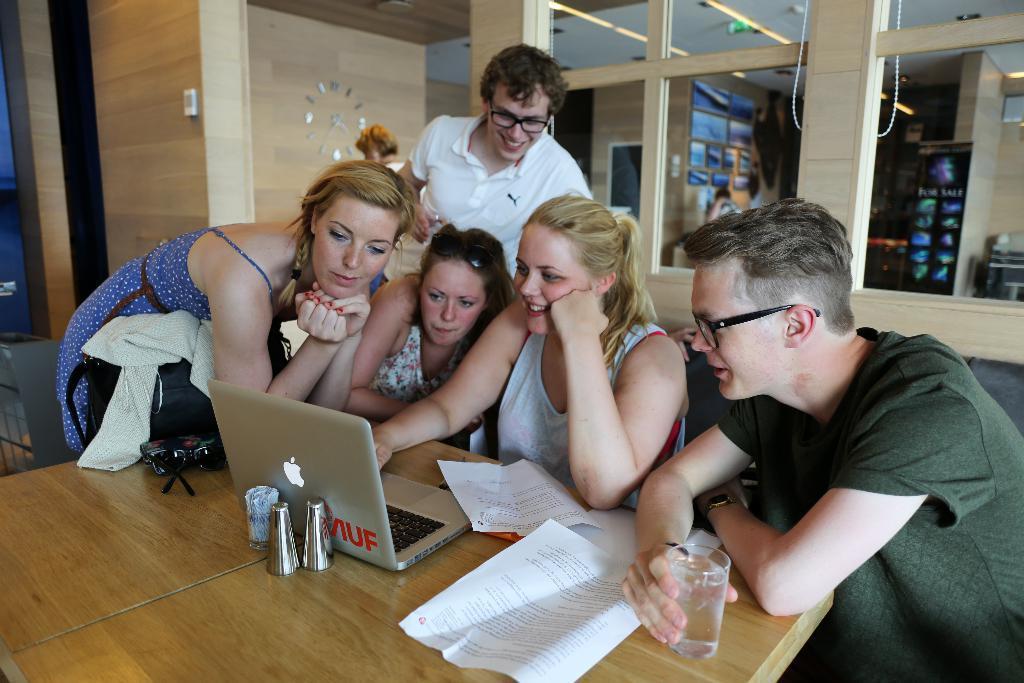How would you summarize this image in a sentence or two? In this image we can see group of persons sitting and some are standing, at the middle of the image there is a person wearing white color dress operating laptop which is on table, there are some glasses, papers on table and also bag and at the background of the image there is wall and cardboard sheets. 